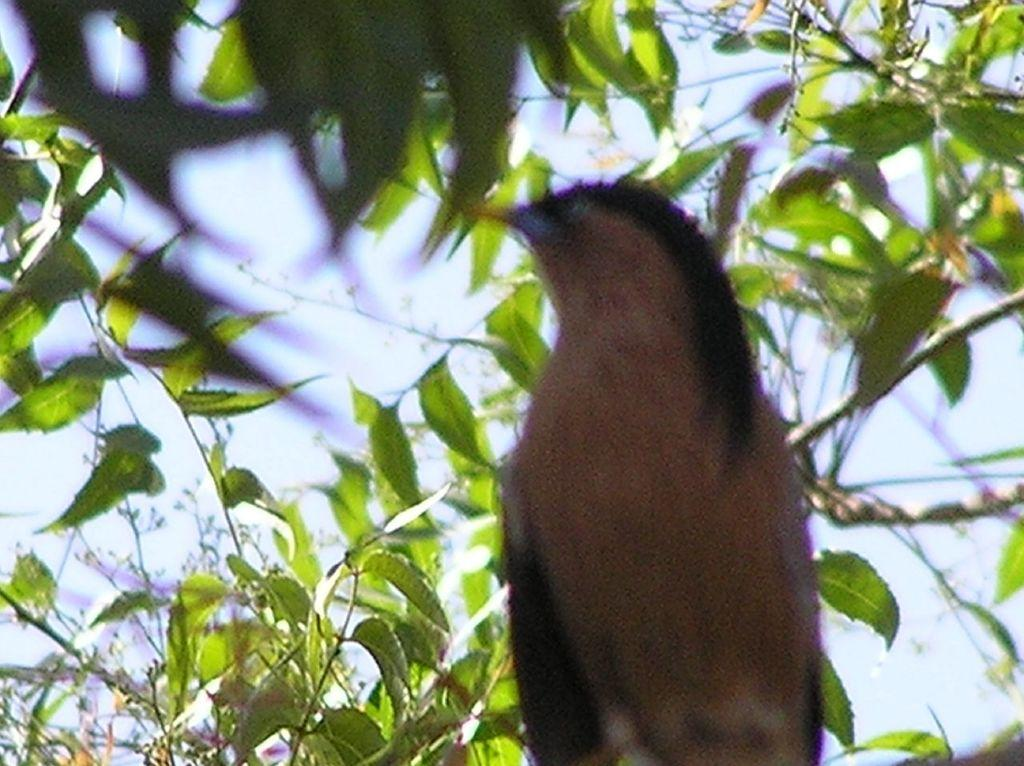What type of animal is present in the image? There is a bird in the image. Where is the bird located? The bird is on a tree. What color are the leaves and stems in the background? The leaves and stems in the background are green. How many years has the bird been folding its wings in the image? There is no indication in the image that the bird has been folding its wings, nor is there any information about the duration of time. 